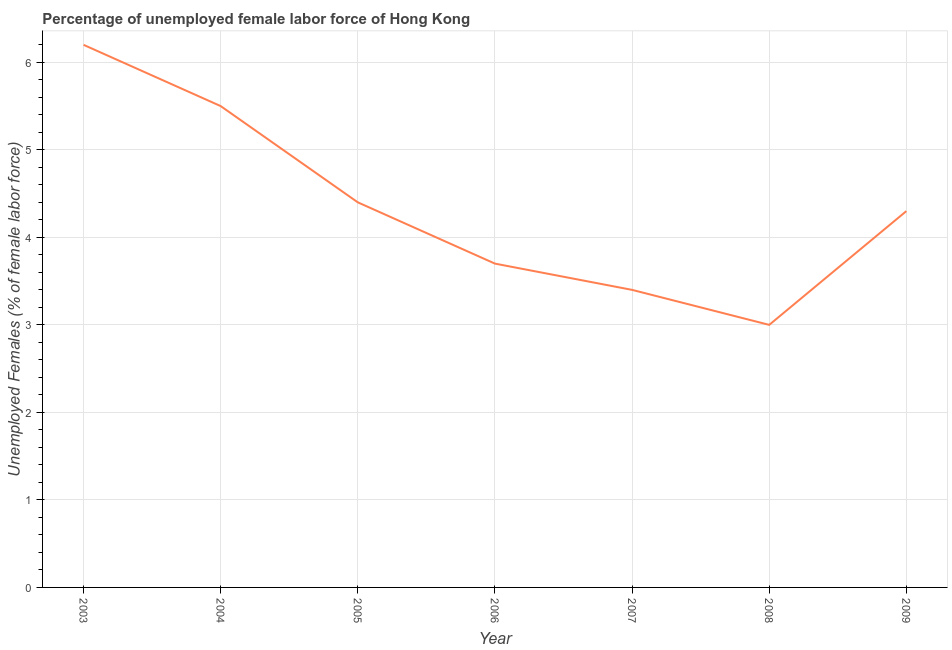Across all years, what is the maximum total unemployed female labour force?
Offer a very short reply. 6.2. In which year was the total unemployed female labour force minimum?
Your answer should be compact. 2008. What is the sum of the total unemployed female labour force?
Give a very brief answer. 30.5. What is the difference between the total unemployed female labour force in 2008 and 2009?
Give a very brief answer. -1.3. What is the average total unemployed female labour force per year?
Your answer should be compact. 4.36. What is the median total unemployed female labour force?
Provide a succinct answer. 4.3. What is the ratio of the total unemployed female labour force in 2003 to that in 2006?
Your response must be concise. 1.68. What is the difference between the highest and the second highest total unemployed female labour force?
Your answer should be compact. 0.7. Is the sum of the total unemployed female labour force in 2004 and 2005 greater than the maximum total unemployed female labour force across all years?
Your response must be concise. Yes. What is the difference between the highest and the lowest total unemployed female labour force?
Keep it short and to the point. 3.2. How many lines are there?
Keep it short and to the point. 1. How many years are there in the graph?
Give a very brief answer. 7. Does the graph contain any zero values?
Give a very brief answer. No. What is the title of the graph?
Provide a succinct answer. Percentage of unemployed female labor force of Hong Kong. What is the label or title of the Y-axis?
Offer a very short reply. Unemployed Females (% of female labor force). What is the Unemployed Females (% of female labor force) of 2003?
Your answer should be compact. 6.2. What is the Unemployed Females (% of female labor force) of 2004?
Your answer should be very brief. 5.5. What is the Unemployed Females (% of female labor force) in 2005?
Your answer should be very brief. 4.4. What is the Unemployed Females (% of female labor force) of 2006?
Give a very brief answer. 3.7. What is the Unemployed Females (% of female labor force) in 2007?
Make the answer very short. 3.4. What is the Unemployed Females (% of female labor force) of 2009?
Ensure brevity in your answer.  4.3. What is the difference between the Unemployed Females (% of female labor force) in 2003 and 2004?
Your answer should be compact. 0.7. What is the difference between the Unemployed Females (% of female labor force) in 2003 and 2006?
Provide a succinct answer. 2.5. What is the difference between the Unemployed Females (% of female labor force) in 2004 and 2005?
Keep it short and to the point. 1.1. What is the difference between the Unemployed Females (% of female labor force) in 2004 and 2007?
Your answer should be compact. 2.1. What is the difference between the Unemployed Females (% of female labor force) in 2005 and 2006?
Provide a succinct answer. 0.7. What is the difference between the Unemployed Females (% of female labor force) in 2005 and 2007?
Your response must be concise. 1. What is the difference between the Unemployed Females (% of female labor force) in 2005 and 2009?
Your response must be concise. 0.1. What is the difference between the Unemployed Females (% of female labor force) in 2006 and 2009?
Ensure brevity in your answer.  -0.6. What is the difference between the Unemployed Females (% of female labor force) in 2007 and 2008?
Ensure brevity in your answer.  0.4. What is the ratio of the Unemployed Females (% of female labor force) in 2003 to that in 2004?
Your answer should be very brief. 1.13. What is the ratio of the Unemployed Females (% of female labor force) in 2003 to that in 2005?
Your answer should be compact. 1.41. What is the ratio of the Unemployed Females (% of female labor force) in 2003 to that in 2006?
Your response must be concise. 1.68. What is the ratio of the Unemployed Females (% of female labor force) in 2003 to that in 2007?
Give a very brief answer. 1.82. What is the ratio of the Unemployed Females (% of female labor force) in 2003 to that in 2008?
Your response must be concise. 2.07. What is the ratio of the Unemployed Females (% of female labor force) in 2003 to that in 2009?
Keep it short and to the point. 1.44. What is the ratio of the Unemployed Females (% of female labor force) in 2004 to that in 2005?
Give a very brief answer. 1.25. What is the ratio of the Unemployed Females (% of female labor force) in 2004 to that in 2006?
Your answer should be compact. 1.49. What is the ratio of the Unemployed Females (% of female labor force) in 2004 to that in 2007?
Make the answer very short. 1.62. What is the ratio of the Unemployed Females (% of female labor force) in 2004 to that in 2008?
Offer a very short reply. 1.83. What is the ratio of the Unemployed Females (% of female labor force) in 2004 to that in 2009?
Your answer should be compact. 1.28. What is the ratio of the Unemployed Females (% of female labor force) in 2005 to that in 2006?
Provide a succinct answer. 1.19. What is the ratio of the Unemployed Females (% of female labor force) in 2005 to that in 2007?
Keep it short and to the point. 1.29. What is the ratio of the Unemployed Females (% of female labor force) in 2005 to that in 2008?
Offer a terse response. 1.47. What is the ratio of the Unemployed Females (% of female labor force) in 2005 to that in 2009?
Make the answer very short. 1.02. What is the ratio of the Unemployed Females (% of female labor force) in 2006 to that in 2007?
Offer a terse response. 1.09. What is the ratio of the Unemployed Females (% of female labor force) in 2006 to that in 2008?
Provide a short and direct response. 1.23. What is the ratio of the Unemployed Females (% of female labor force) in 2006 to that in 2009?
Offer a terse response. 0.86. What is the ratio of the Unemployed Females (% of female labor force) in 2007 to that in 2008?
Ensure brevity in your answer.  1.13. What is the ratio of the Unemployed Females (% of female labor force) in 2007 to that in 2009?
Your answer should be very brief. 0.79. What is the ratio of the Unemployed Females (% of female labor force) in 2008 to that in 2009?
Ensure brevity in your answer.  0.7. 